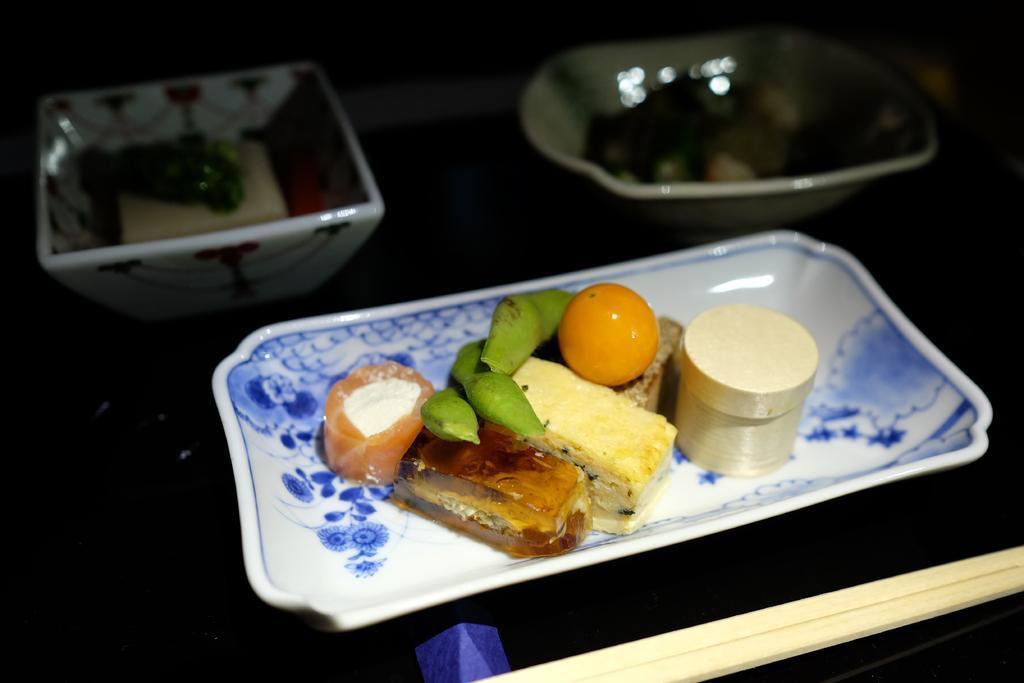Describe this image in one or two sentences. In the foreground of the picture there is a table, on the table there are bowl, plate, platter and dishes. 